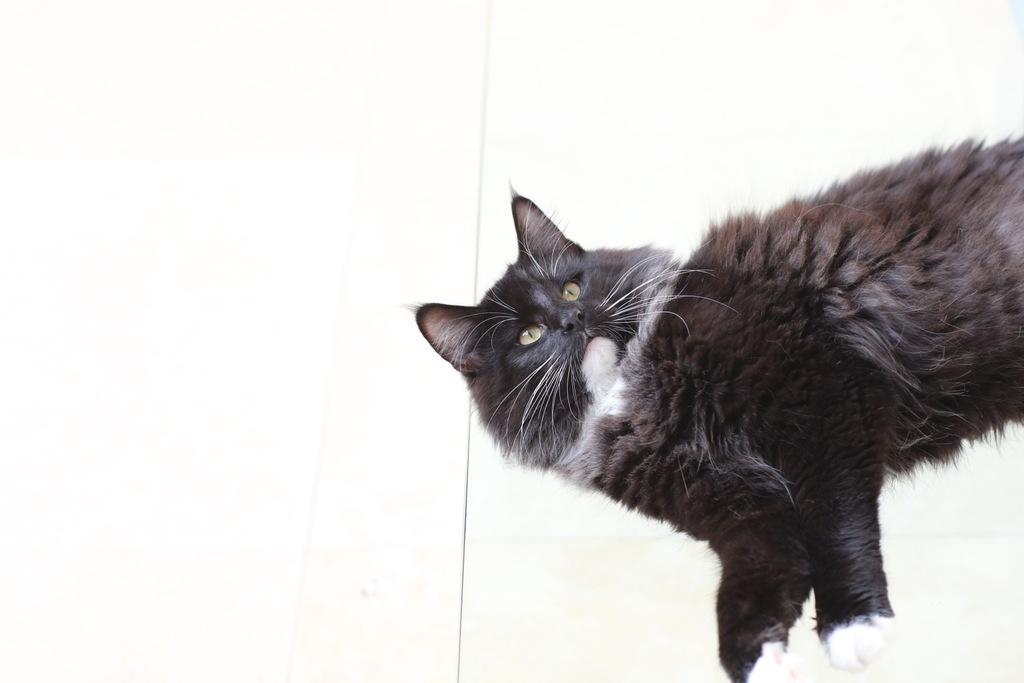What type of animal is in the image? There is a black cat in the image. Where is the cat positioned in the image? The cat is standing on the left side. What color is the background of the image? The background of the image is white in color. What type of spot does the queen sit on in the image? There is no queen or spot present in the image; it features a black cat standing on the left side against a white background. 